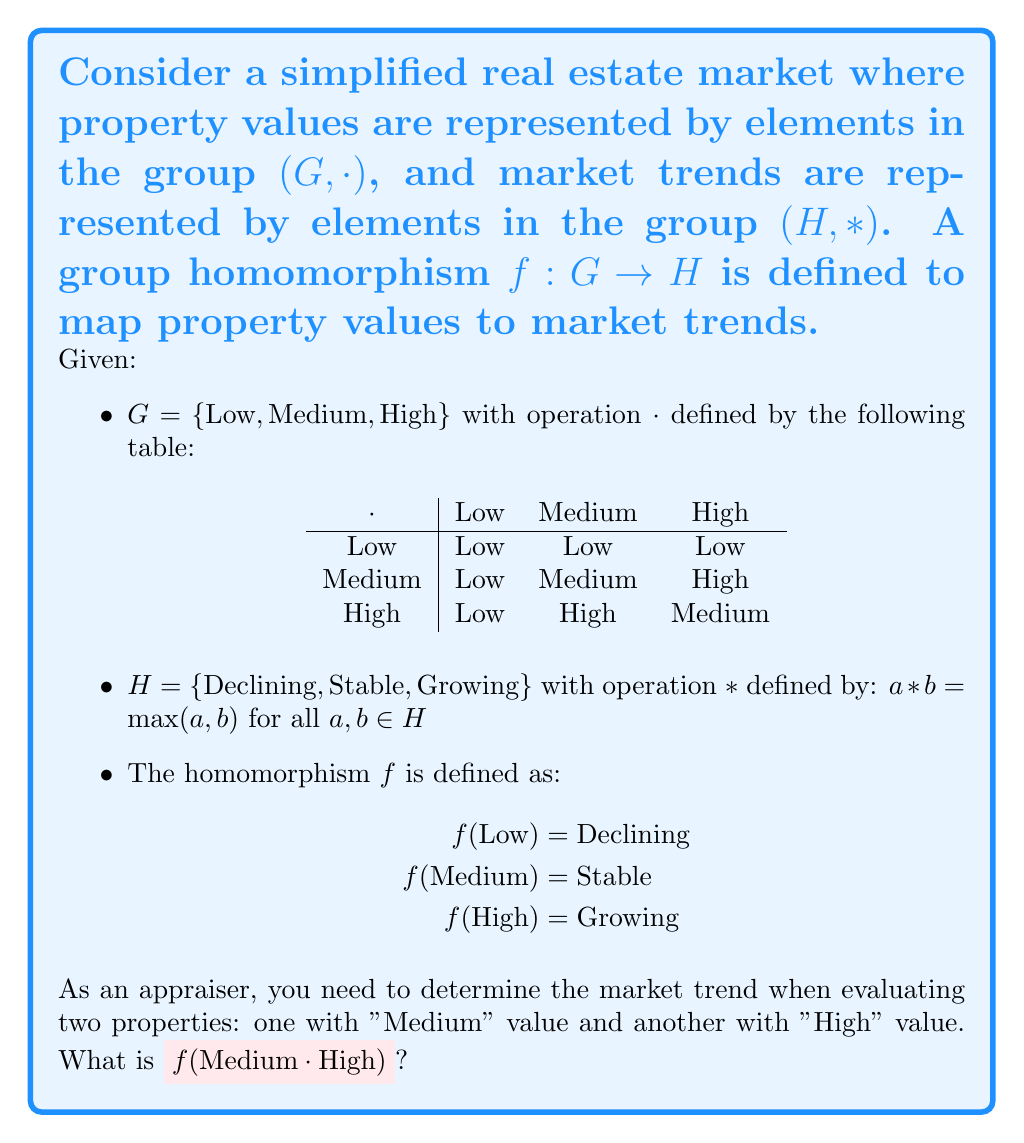Teach me how to tackle this problem. To solve this problem, we'll follow these steps:

1) First, we need to determine $\text{Medium} \cdot \text{High}$ in group $G$. From the given operation table, we can see that:

   $\text{Medium} \cdot \text{High} = \text{High}$

2) Now that we know $\text{Medium} \cdot \text{High} = \text{High}$, we need to find $f(\text{High})$.

3) From the definition of the homomorphism $f$, we know that:

   $f(\text{High}) = \text{Growing}$

4) Therefore, $f(\text{Medium} \cdot \text{High}) = f(\text{High}) = \text{Growing}$

5) We can verify that this satisfies the homomorphism property:

   $f(\text{Medium}) * f(\text{High}) = \text{Stable} * \text{Growing} = \max(\text{Stable}, \text{Growing}) = \text{Growing}$

   Which is indeed equal to $f(\text{Medium} \cdot \text{High})$, confirming that $f$ is a homomorphism.

As an appraiser, this result indicates that when evaluating two properties, one of medium value and one of high value, the overall market trend for this combination is growing.
Answer: Growing 